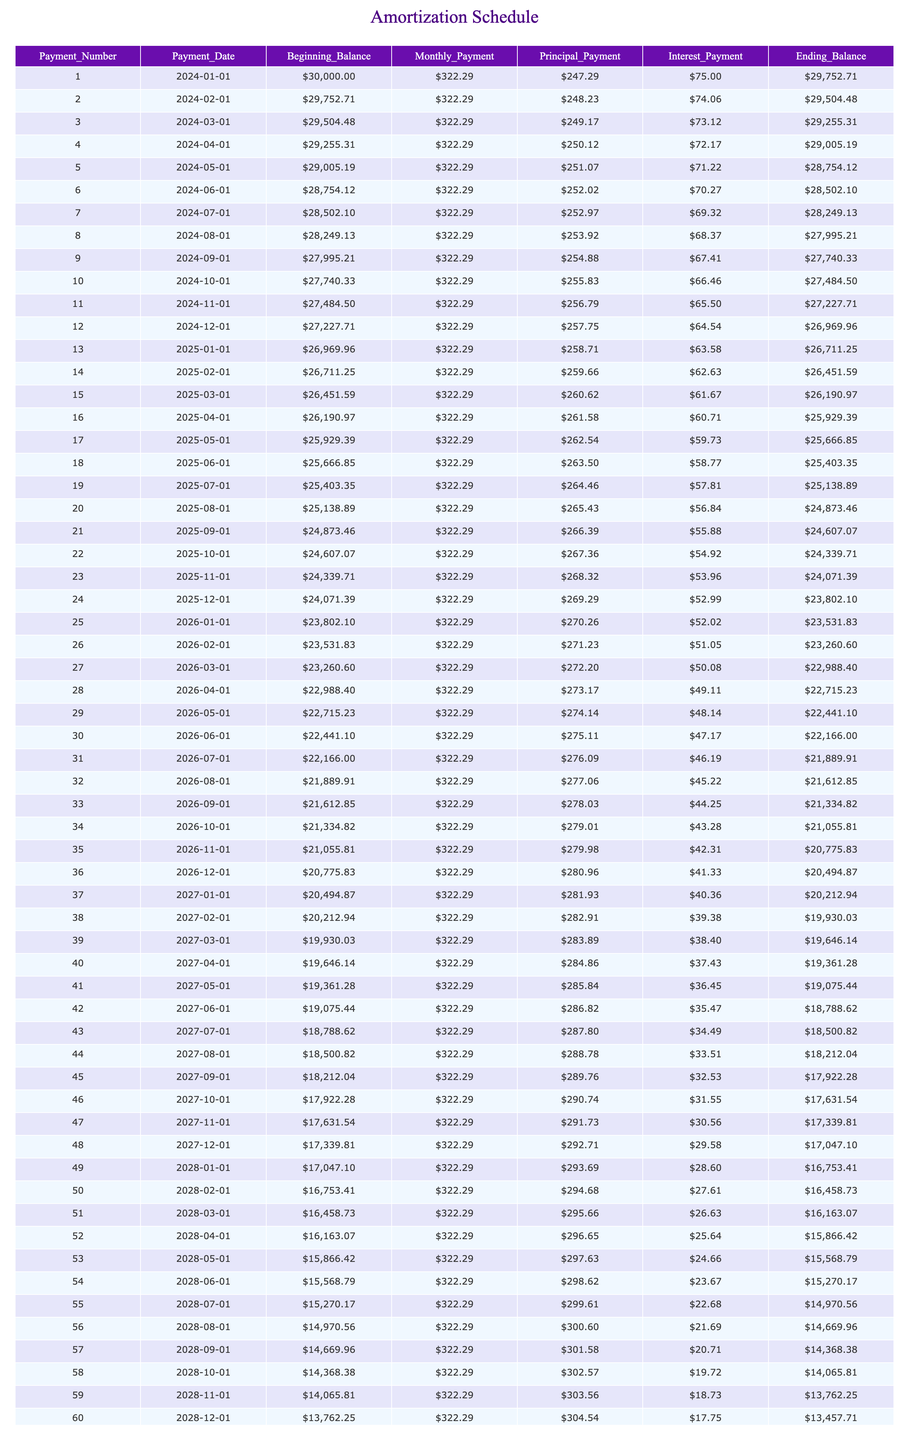What is the monthly payment amount for the student loan? The monthly payment amount can be found in the "Monthly_Payment" column. All entries show a consistent value of $322.29. Therefore, the monthly payment is a fixed amount.
Answer: $322.29 How much interest is paid in the 10th payment? To find the interest paid in the 10th payment, refer to the "Interest_Payment" column for row 10. The interest amount is $66.46.
Answer: $66.46 What is the total principal paid after the first five payments? To calculate the total principal paid after the first five payments, sum the values in the "Principal_Payment" column for payments 1 through 5: 247.29 + 248.23 + 249.17 + 250.12 + 251.07 = 1,246.88.
Answer: $1,246.88 Does the interest payment decrease over time? From the table, it is evident that each subsequent payment shows a decreasing amount in the "Interest_Payment" column, indicating that the interest payment does decrease as the balance is paid down.
Answer: Yes What is the beginning balance before the first payment? Look at the "Beginning_Balance" column for the first row, which indicates the amount owed before any payments. The beginning balance before the first payment is $30,000.00.
Answer: $30,000.00 What is the average amount of principal paid over the first 12 payments? First, sum the principal amounts for the first twelve payments: 247.29 + 248.23 + 249.17 + 250.12 + 251.07 + 252.02 + 252.97 + 253.92 + 254.88 + 255.83 + 256.79 + 257.75 = 3,030.65. Next, divide by 12 to find the average: 3,030.65 / 12 ≈ 252.55.
Answer: $252.55 How much was the ending balance after the 36th payment? Check the "Ending_Balance" column for the 36th payment, which shows the remaining loan balance after that payment. The ending balance after the 36th payment is $20,494.87.
Answer: $20,494.87 What was the total interest paid by the end of the first year (12 payments)? To find the total interest paid in the first year, sum all the interest payments from the "Interest_Payment" column for payments 1 to 12: 75.00 + 74.06 + 73.12 + 72.17 + 71.22 + 70.27 + 69.32 + 68.37 + 67.41 + 66.46 + 65.50 + 64.54 = 835.20.
Answer: $835.20 Is the ending balance after the 60th payment zero? The ending balance after the 60th payment is $0.00, which indicates that the loan has been fully paid off after the last payment.
Answer: Yes 